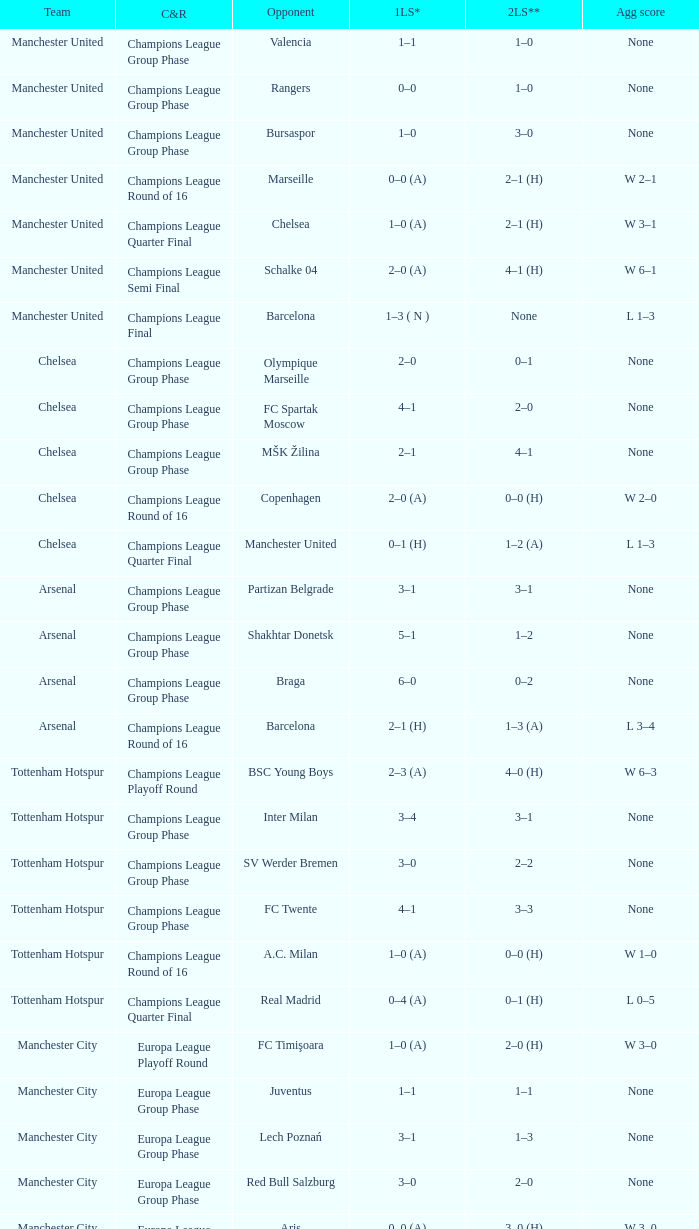What was the score between Marseille and Manchester United on the second leg of the Champions League Round of 16? 2–1 (H). 